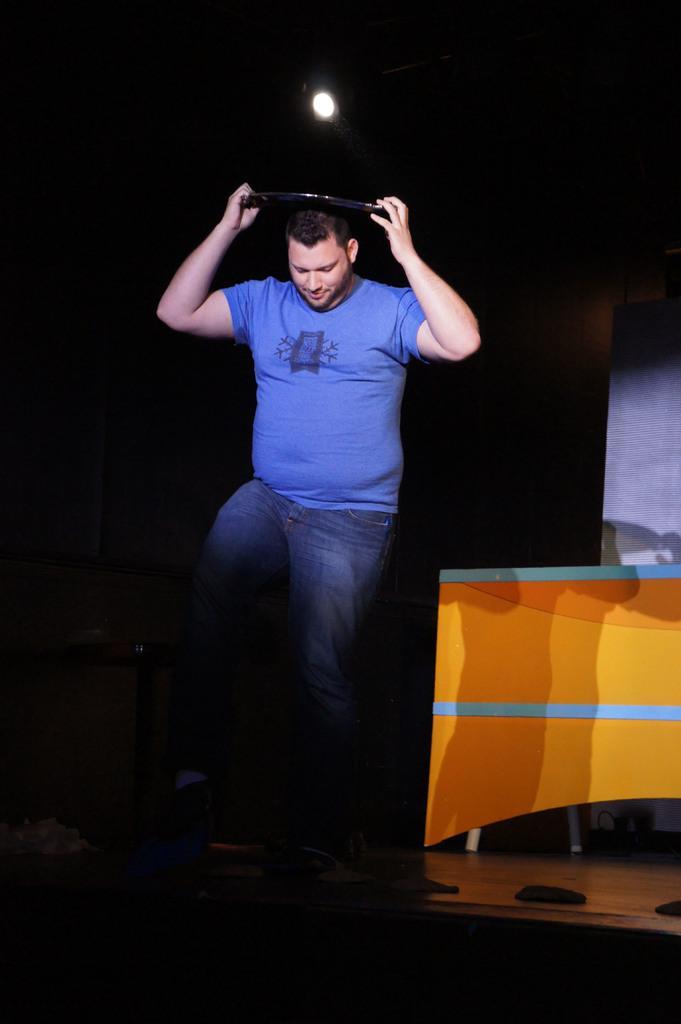In one or two sentences, can you explain what this image depicts? In the image there is a man standing on a stage holding a disc over his head, he is wearing blue t-shirt and jeans, On the left side there is a table and above there is a light on the ceiling. 